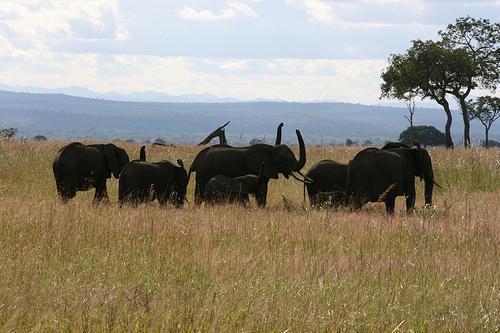How many broken trees are visible?
Give a very brief answer. 1. 